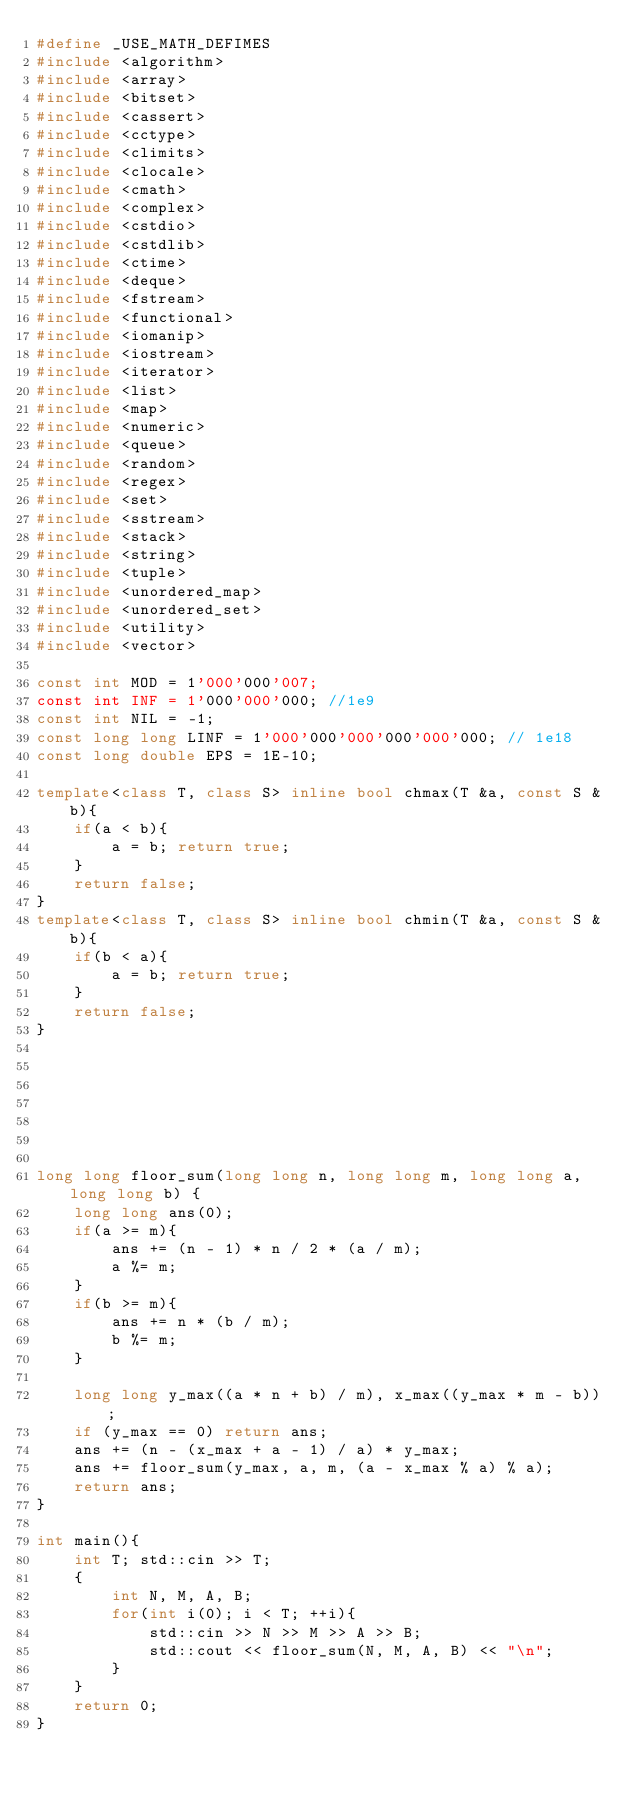<code> <loc_0><loc_0><loc_500><loc_500><_C++_>#define _USE_MATH_DEFIMES
#include <algorithm>
#include <array>
#include <bitset>
#include <cassert>
#include <cctype>
#include <climits>
#include <clocale>
#include <cmath>
#include <complex>
#include <cstdio>
#include <cstdlib>
#include <ctime>
#include <deque>
#include <fstream>
#include <functional>
#include <iomanip>
#include <iostream>
#include <iterator>
#include <list>
#include <map>
#include <numeric>
#include <queue>
#include <random>
#include <regex>
#include <set>
#include <sstream>
#include <stack>
#include <string>
#include <tuple>
#include <unordered_map>
#include <unordered_set>
#include <utility>
#include <vector>

const int MOD = 1'000'000'007;
const int INF = 1'000'000'000; //1e9
const int NIL = -1;
const long long LINF = 1'000'000'000'000'000'000; // 1e18
const long double EPS = 1E-10;

template<class T, class S> inline bool chmax(T &a, const S &b){
    if(a < b){
        a = b; return true;
    }
    return false;
}
template<class T, class S> inline bool chmin(T &a, const S &b){
    if(b < a){
        a = b; return true;
    }
    return false;
}







long long floor_sum(long long n, long long m, long long a, long long b) {
    long long ans(0);
    if(a >= m){
        ans += (n - 1) * n / 2 * (a / m);
        a %= m;
    }
    if(b >= m){
        ans += n * (b / m);
        b %= m;
    }

    long long y_max((a * n + b) / m), x_max((y_max * m - b));
    if (y_max == 0) return ans;
    ans += (n - (x_max + a - 1) / a) * y_max;
    ans += floor_sum(y_max, a, m, (a - x_max % a) % a);
    return ans;
}

int main(){
    int T; std::cin >> T;
    {
        int N, M, A, B;
        for(int i(0); i < T; ++i){
            std::cin >> N >> M >> A >> B;
            std::cout << floor_sum(N, M, A, B) << "\n";
        }
    }
    return 0;
}
</code> 